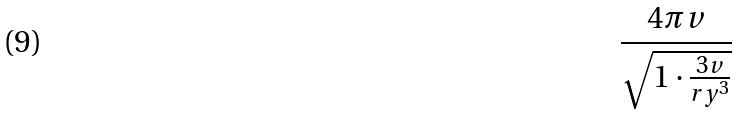Convert formula to latex. <formula><loc_0><loc_0><loc_500><loc_500>\frac { 4 \pi v } { \sqrt { 1 \cdot \frac { 3 v } { r y ^ { 3 } } } }</formula> 